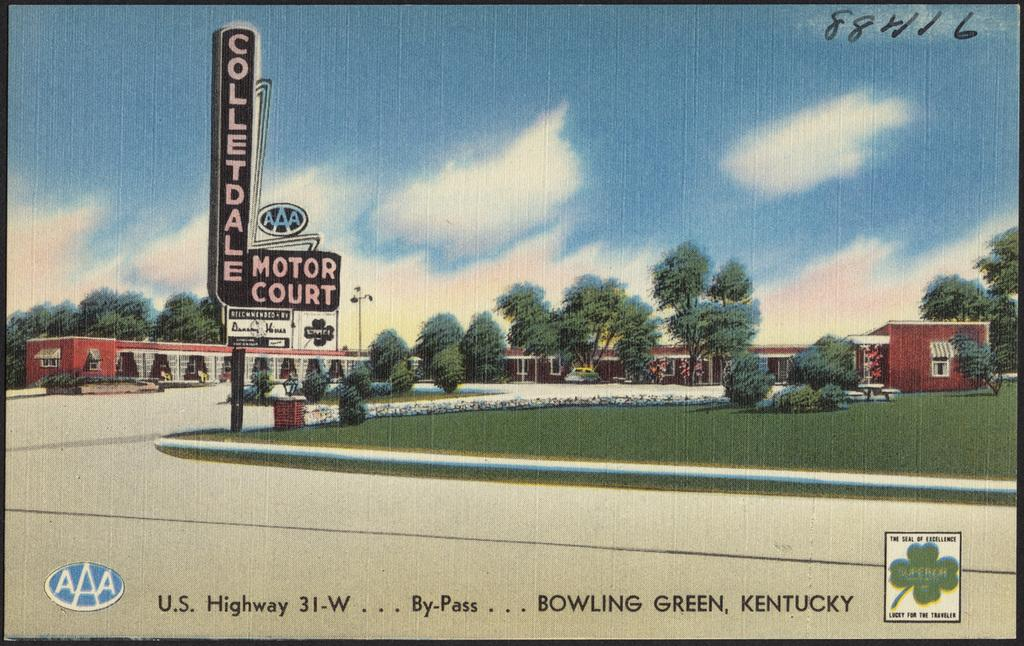<image>
Present a compact description of the photo's key features. aaa postcard for the colletdale motor court in bowling green kentucky 